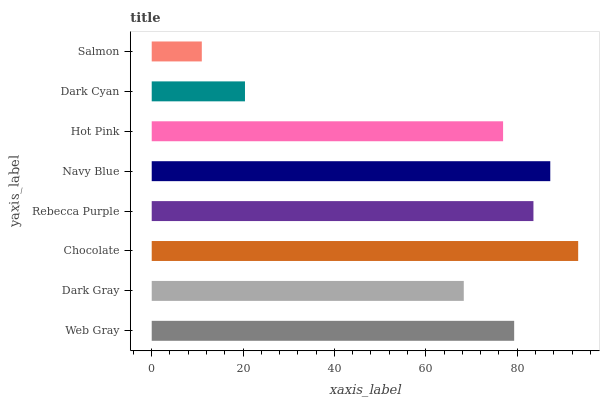Is Salmon the minimum?
Answer yes or no. Yes. Is Chocolate the maximum?
Answer yes or no. Yes. Is Dark Gray the minimum?
Answer yes or no. No. Is Dark Gray the maximum?
Answer yes or no. No. Is Web Gray greater than Dark Gray?
Answer yes or no. Yes. Is Dark Gray less than Web Gray?
Answer yes or no. Yes. Is Dark Gray greater than Web Gray?
Answer yes or no. No. Is Web Gray less than Dark Gray?
Answer yes or no. No. Is Web Gray the high median?
Answer yes or no. Yes. Is Hot Pink the low median?
Answer yes or no. Yes. Is Dark Cyan the high median?
Answer yes or no. No. Is Rebecca Purple the low median?
Answer yes or no. No. 